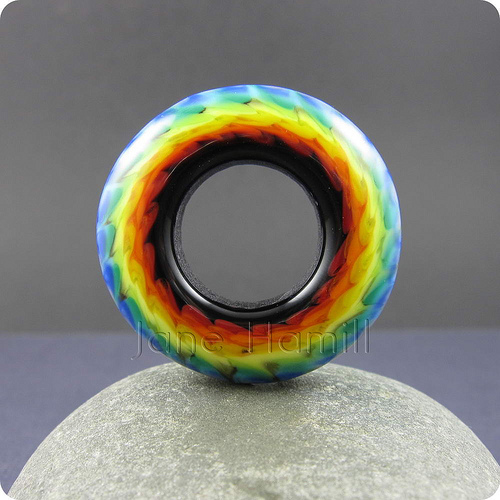<image>
Is the donut above the rock? Yes. The donut is positioned above the rock in the vertical space, higher up in the scene. 